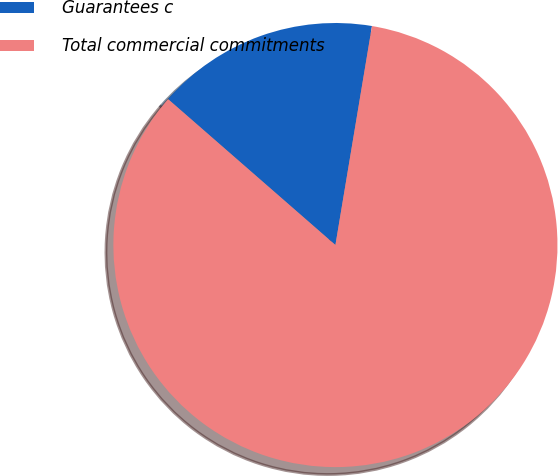<chart> <loc_0><loc_0><loc_500><loc_500><pie_chart><fcel>Guarantees c<fcel>Total commercial commitments<nl><fcel>16.22%<fcel>83.78%<nl></chart> 